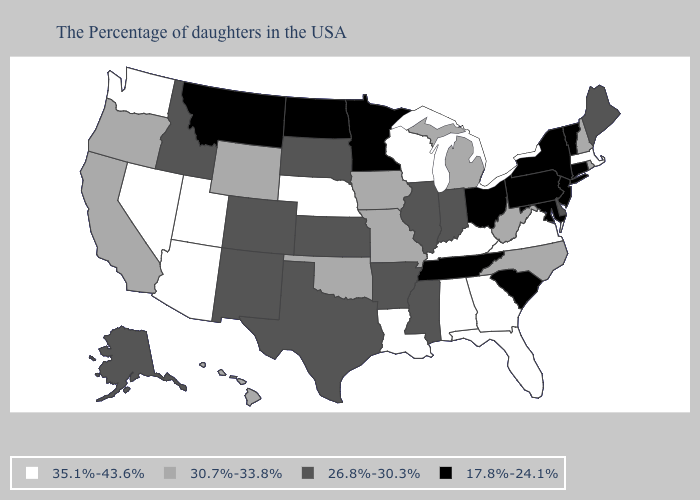Which states hav the highest value in the Northeast?
Keep it brief. Massachusetts. Name the states that have a value in the range 17.8%-24.1%?
Answer briefly. Vermont, Connecticut, New York, New Jersey, Maryland, Pennsylvania, South Carolina, Ohio, Tennessee, Minnesota, North Dakota, Montana. Does Massachusetts have a higher value than Rhode Island?
Answer briefly. Yes. Name the states that have a value in the range 26.8%-30.3%?
Be succinct. Maine, Delaware, Indiana, Illinois, Mississippi, Arkansas, Kansas, Texas, South Dakota, Colorado, New Mexico, Idaho, Alaska. Which states have the lowest value in the USA?
Write a very short answer. Vermont, Connecticut, New York, New Jersey, Maryland, Pennsylvania, South Carolina, Ohio, Tennessee, Minnesota, North Dakota, Montana. Does the map have missing data?
Give a very brief answer. No. Name the states that have a value in the range 26.8%-30.3%?
Give a very brief answer. Maine, Delaware, Indiana, Illinois, Mississippi, Arkansas, Kansas, Texas, South Dakota, Colorado, New Mexico, Idaho, Alaska. Which states hav the highest value in the Northeast?
Short answer required. Massachusetts. Does Montana have the lowest value in the USA?
Short answer required. Yes. Among the states that border Connecticut , which have the highest value?
Write a very short answer. Massachusetts. Does the map have missing data?
Quick response, please. No. Among the states that border Wisconsin , does Iowa have the highest value?
Give a very brief answer. Yes. What is the value of New Hampshire?
Write a very short answer. 30.7%-33.8%. Does Nevada have the lowest value in the USA?
Concise answer only. No. 